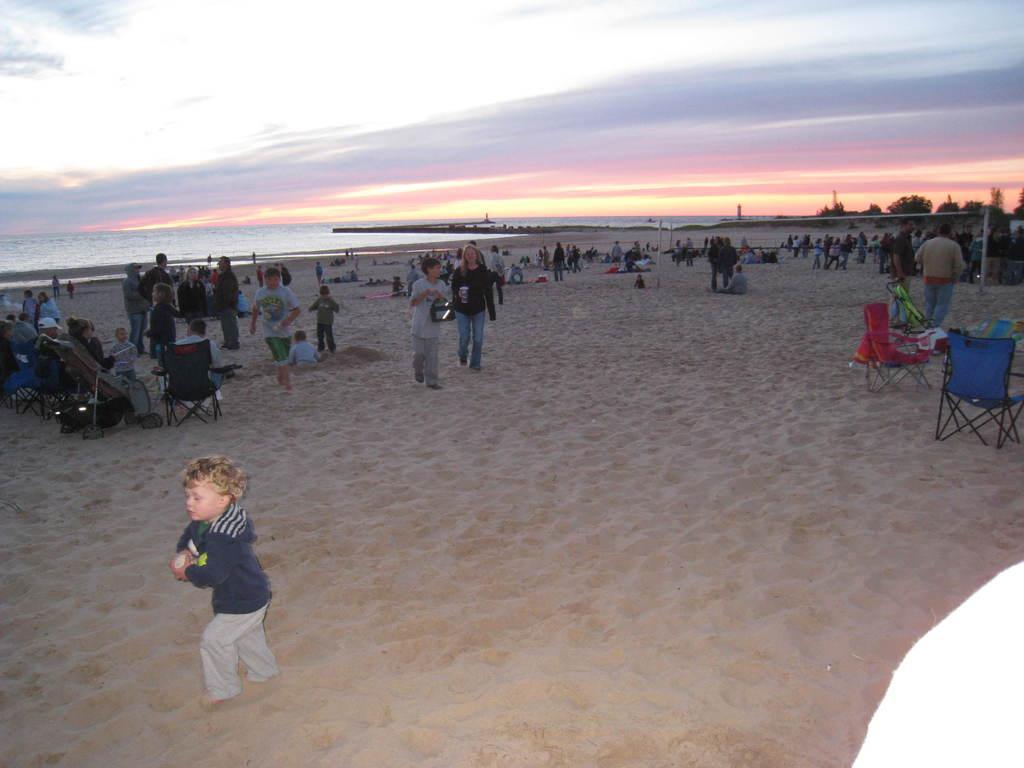Please provide a concise description of this image. This is a beach. On the right side there are few empty chairs and a crowd of people standing. On the left side a child is standing on the ground and there are few people sitting on the chairs. I can see the sand on the ground. In the background there is an ocean. On the right side there are some trees. At the top of the image I can see the sky. 